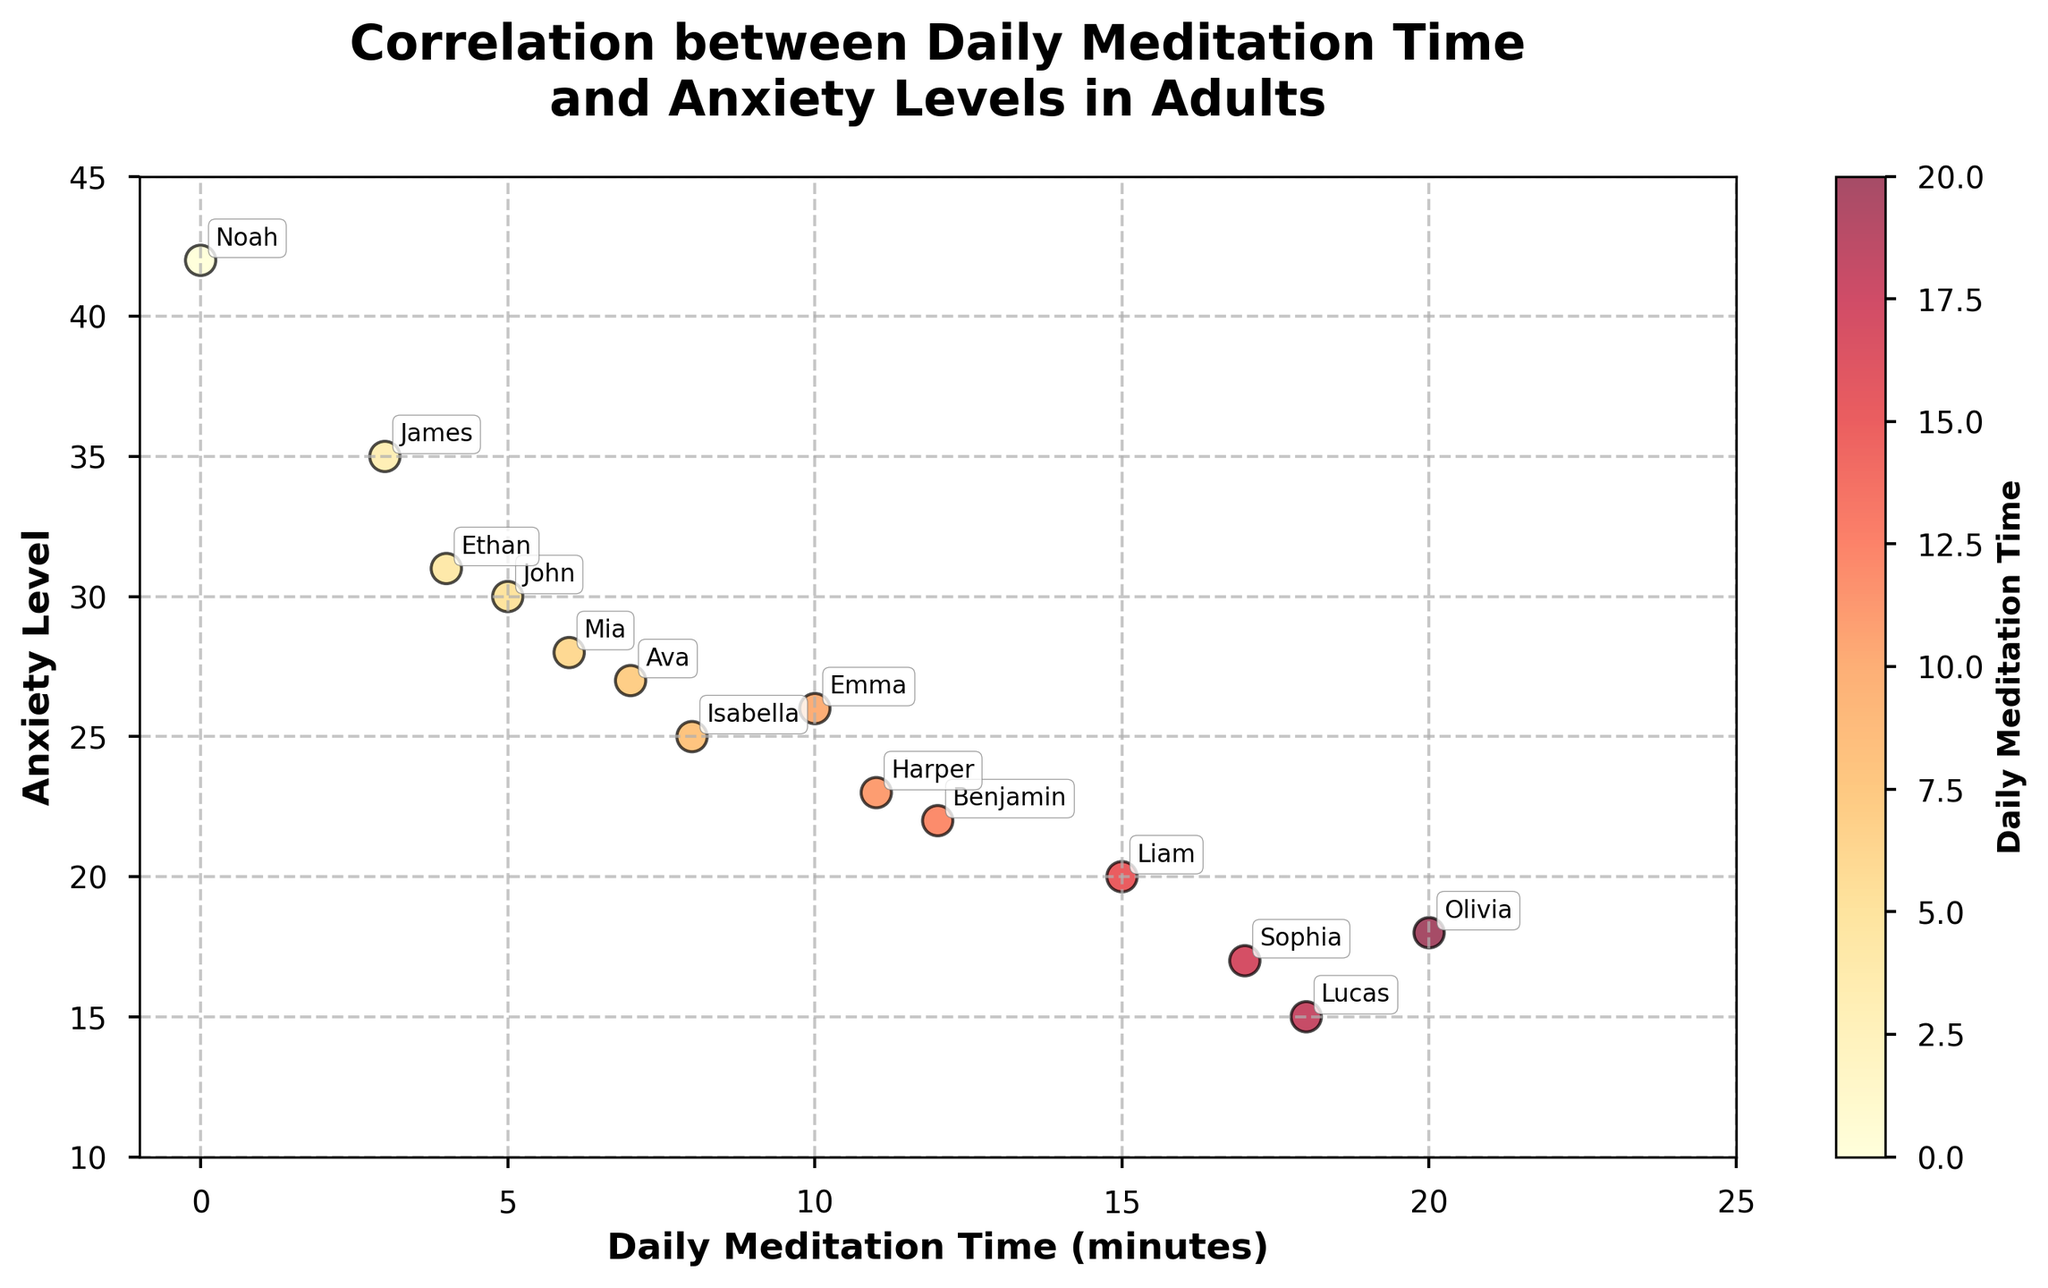How many participants are displayed in the figure? Count the number of points on the scatter plot. There are 14 points, representing 14 participants.
Answer: 14 What is the title of the figure? Read the title presented at the top of the figure: "Correlation between Daily Meditation Time and Anxiety Levels in Adults".
Answer: "Correlation between Daily Meditation Time and Anxiety Levels in Adults" What is the participant with the highest anxiety level, and what is their meditation time? Look for the data point with the highest value on the Y-axis (Anxiety Level). Noah has the highest anxiety level at 42, and his daily meditation time is 0 minutes.
Answer: Noah, 0 minutes Which participant has the lowest anxiety level, and how much time do they spend meditating daily? Look for the data point with the lowest value on the Y-axis (Anxiety Level). Sophia has the lowest anxiety level at 17, and she spends 17 minutes meditating daily.
Answer: Sophia, 17 minutes What can be inferred about the relationship between daily meditation time and anxiety levels from the scatter plot? Observing the general trend of points, it appears that participants who meditate more tend to have lower anxiety levels, indicating a negative correlation between meditation time and anxiety.
Answer: Negative correlation Which two participants have the closest levels of anxiety, and what are their respective meditation times? Identify closely positioned points on the Y-axis. Liam (20) and Benjamin (22) have close anxiety levels, with 15 and 12 minutes of meditation time, respectively.
Answer: Liam (15 min) and Benjamin (12 min) What is the range of daily meditation times? Calculate the difference between the maximum and minimum values on the X-axis for daily meditation times. The range is from 0 to 20 minutes.
Answer: 20 minutes Compare the anxiety levels of the participant with the highest daily meditation time and the participant with the lowest daily meditation time. The participant with the highest daily meditation time (Olivia, 20 minutes) has an anxiety level of 18, while the participant with the lowest daily meditation time (Noah, 0 minutes) has an anxiety level of 42.
Answer: Olivia (18) vs Noah (42) Do participants who meditate more than 15 minutes daily generally have lower anxiety levels than those who meditate less than 10 minutes daily? Separate the participants into two groups (>15 minutes and <10 minutes). For >15 minutes (Olivia, Lucas, Sophia): anxiety levels are 18, 15, 17. For <10 minutes (John, Noah, Mia, Ethan, James): anxiety levels are 30, 42, 28, 31, 35. The first group generally has lower anxiety levels.
Answer: Yes How are the participants annotated on the scatter plot? Participants' names are displayed next to their corresponding points through annotations with a small offset to avoid overlap, ensuring clarity and readability.
Answer: By name annotation 